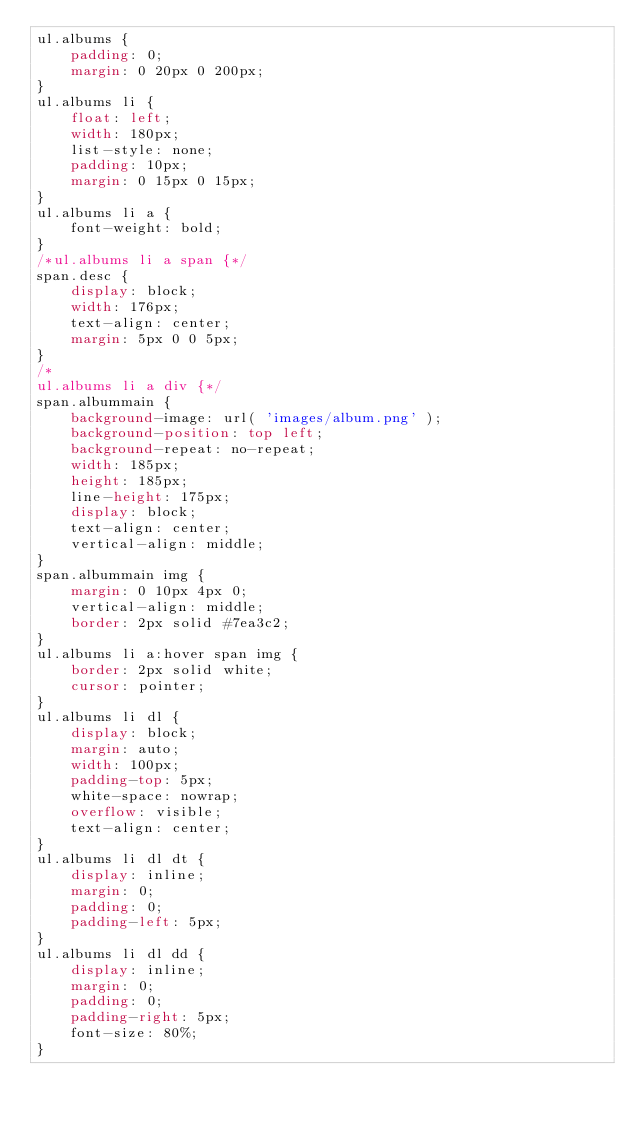<code> <loc_0><loc_0><loc_500><loc_500><_CSS_>ul.albums {
    padding: 0;
    margin: 0 20px 0 200px;
}
ul.albums li {
    float: left;
    width: 180px;
    list-style: none;
    padding: 10px;
    margin: 0 15px 0 15px;
}
ul.albums li a {
    font-weight: bold;
}
/*ul.albums li a span {*/
span.desc {
    display: block;
    width: 176px;
    text-align: center;
    margin: 5px 0 0 5px;
}
/*
ul.albums li a div {*/
span.albummain {
    background-image: url( 'images/album.png' );
    background-position: top left;
    background-repeat: no-repeat;
    width: 185px;
    height: 185px;
    line-height: 175px;
    display: block;
    text-align: center;
    vertical-align: middle;
}
span.albummain img {
    margin: 0 10px 4px 0;
    vertical-align: middle;
    border: 2px solid #7ea3c2;
}
ul.albums li a:hover span img {
    border: 2px solid white;
    cursor: pointer;
}
ul.albums li dl {
    display: block;
    margin: auto;
    width: 100px;
    padding-top: 5px;
    white-space: nowrap;
    overflow: visible;
    text-align: center;
}
ul.albums li dl dt {
    display: inline;
    margin: 0;
    padding: 0;
    padding-left: 5px;
}
ul.albums li dl dd {
    display: inline;
    margin: 0;
    padding: 0;
    padding-right: 5px;
    font-size: 80%;
}
</code> 